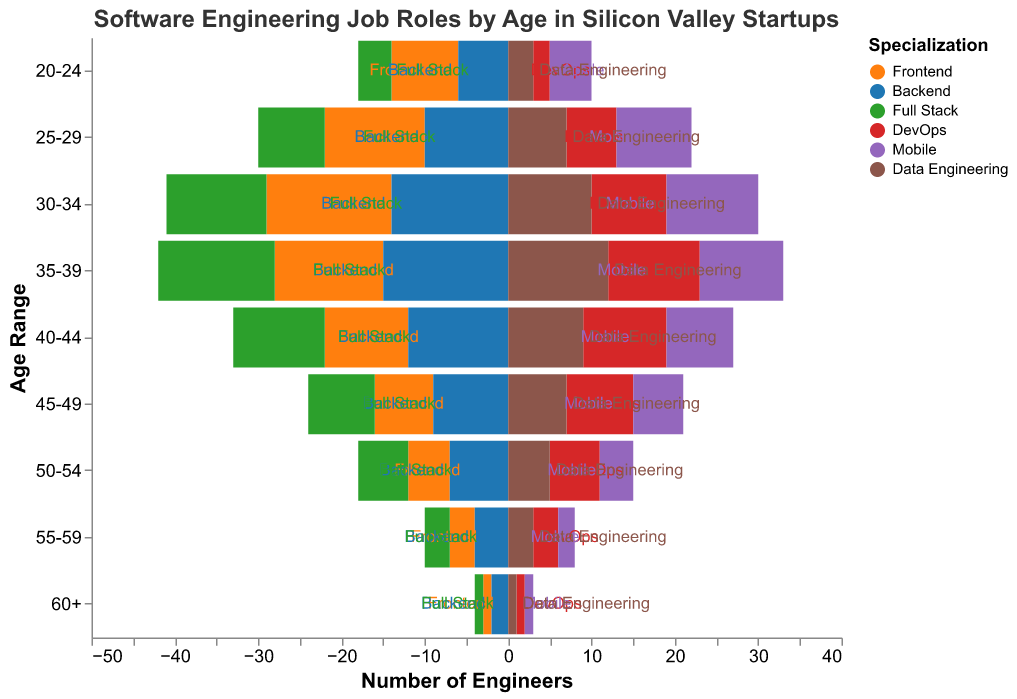What does the title of the chart indicate? The chart's title "Software Engineering Job Roles by Age in Silicon Valley Startups" indicates that the figure shows the distribution of various software engineering roles across different age ranges in Silicon Valley startups.
Answer: Software Engineering Job Roles by Age in Silicon Valley Startups Which age range has the highest number of front-end engineers? To find the age range with the highest number of front-end engineers, look at the bars corresponding to "Frontend" and compare their lengths. The "30-34" age range has the longest bar for front-end engineers.
Answer: 30-34 How many backend engineers are there in the 30-34 age range? Find the bar segment corresponding to "Backend" within the "30-34" age range. The height of this segment represents the number of backend engineers, which is 14.
Answer: 14 In which age range is the number of DevOps engineers equal to 6? Look for the segments labeled "DevOps" and identify the age range where the bar segment's value equals 6. This value appears in the "25-29" and "50-54" age ranges.
Answer: 25-29 and 50-54 Which specialization has the fewest engineers in the 50-54 age range? Compare the bar segment lengths for different specializations within the "50-54" age range. The shortest bar segment is for "Mobile," which represents the smallest number.
Answer: Mobile What is the total number of software engineers aged 20-24? Sum the values of all specializations within the "20-24" age range: Frontend (8) + Backend (6) + Full Stack (4) + DevOps (2) + Mobile (5) + Data Engineering (3). The total is 8 + 6 + 4 + 2 + 5 + 3 = 28.
Answer: 28 Which specialization shows the greatest decrease in the number of engineers from the 30-34 age range to the 40-44 age range? Compute the difference in the number of engineers for each specialization between the two age ranges: Frontend (15-10), Backend (14-12), Full Stack (12-11), DevOps (9-10), Mobile (11-8), Data Engineering (10-9). The greatest decrease is 5 in "Frontend".
Answer: Frontend Compare the number of mobile engineers in the 25-29 age range to the 35-39 age range. Look at the bar segments for "Mobile" in both age ranges. There are 9 mobile engineers in the 25-29 age range and 10 in the 35-39 age range, indicating that there is 1 more engineer in the latter group.
Answer: 1 more in the 35-39 age range What is the average number of front-end engineers across all age ranges? Sum the number of front-end engineers across all age ranges (8 + 12 + 15 + 13 + 10 + 7 + 5 + 3 + 1) and then divide by the number of age ranges (9). The sum is 74, so the average is 74/9 ≈ 8.2.
Answer: 8.2 In which age range do we see the largest number of full stack engineers? Compare the bar segments for "Full Stack" across all age ranges. The age range "35-39" has the longest segment for full stack engineers, which is 14.
Answer: 35-39 